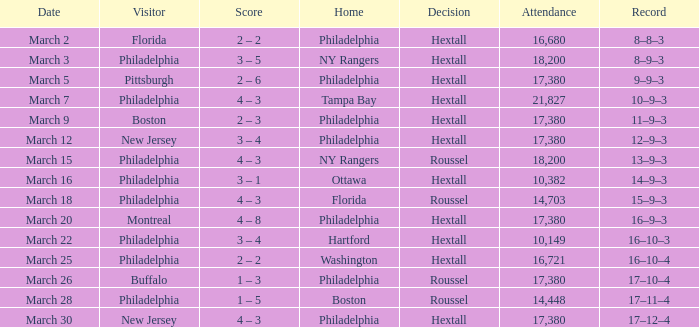On march 30th, which home is being referred to? Philadelphia. 